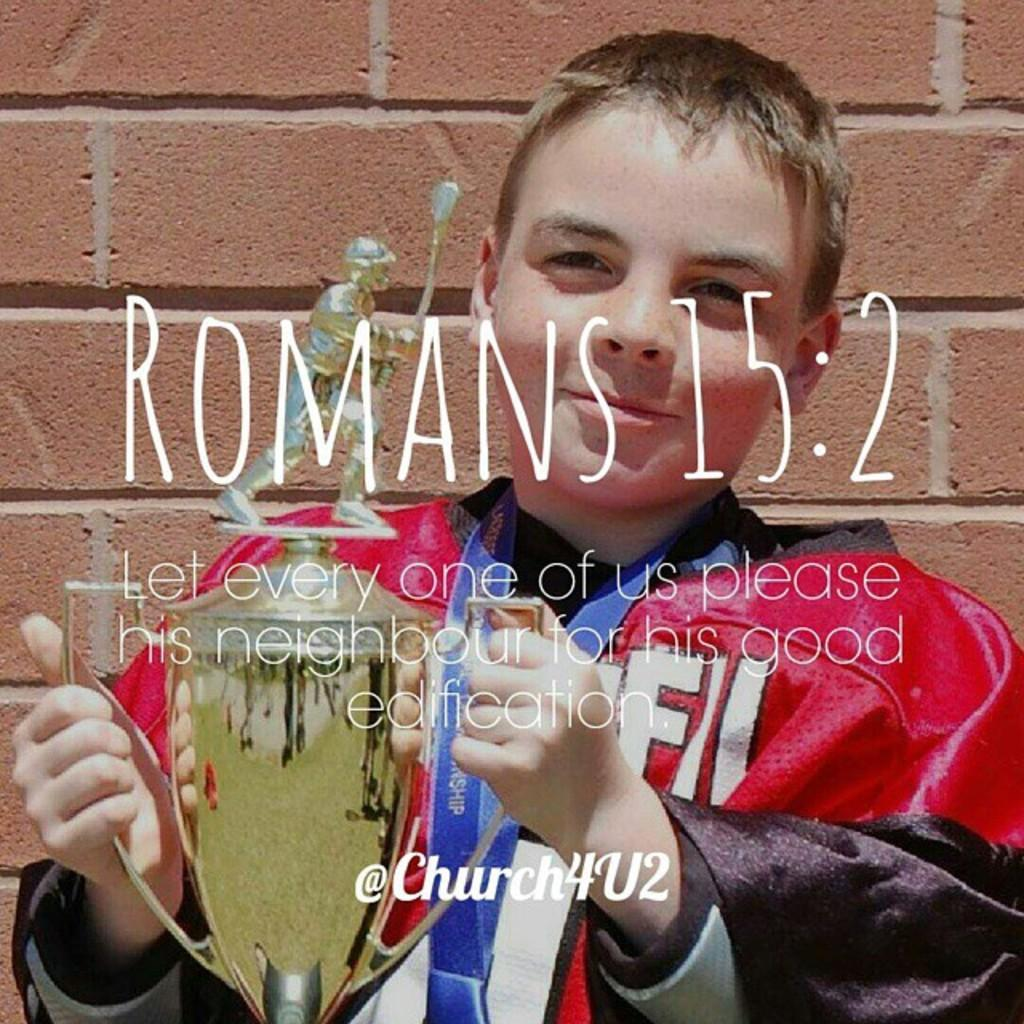<image>
Give a short and clear explanation of the subsequent image. A poster for Romans 15:2 with the twitter handle @church4u2 on the bottom of the picture. 